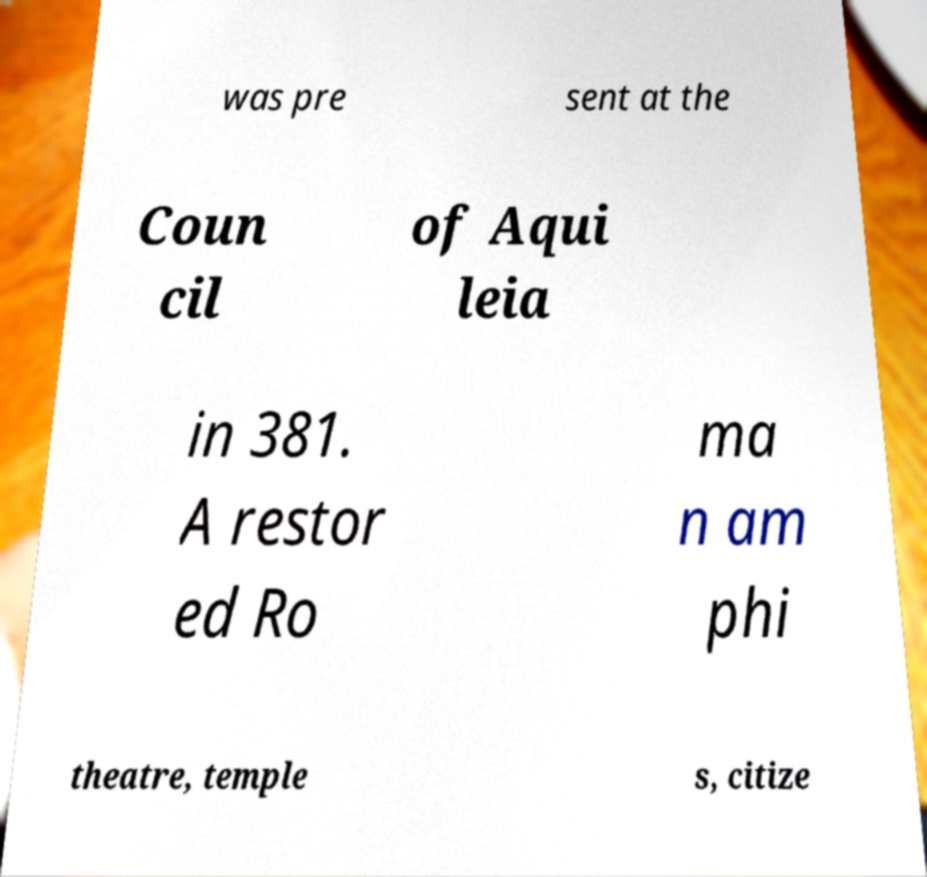There's text embedded in this image that I need extracted. Can you transcribe it verbatim? was pre sent at the Coun cil of Aqui leia in 381. A restor ed Ro ma n am phi theatre, temple s, citize 